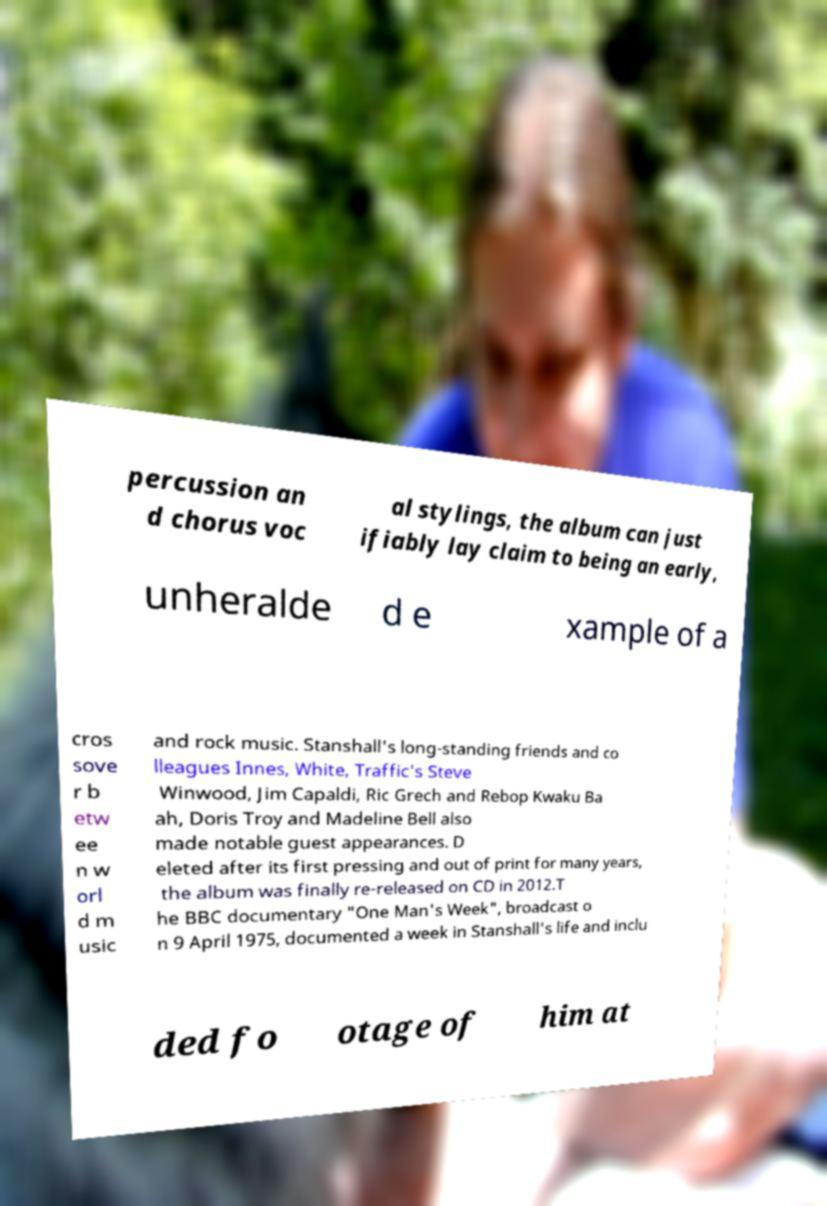Could you assist in decoding the text presented in this image and type it out clearly? percussion an d chorus voc al stylings, the album can just ifiably lay claim to being an early, unheralde d e xample of a cros sove r b etw ee n w orl d m usic and rock music. Stanshall's long-standing friends and co lleagues Innes, White, Traffic's Steve Winwood, Jim Capaldi, Ric Grech and Rebop Kwaku Ba ah, Doris Troy and Madeline Bell also made notable guest appearances. D eleted after its first pressing and out of print for many years, the album was finally re-released on CD in 2012.T he BBC documentary "One Man's Week", broadcast o n 9 April 1975, documented a week in Stanshall's life and inclu ded fo otage of him at 